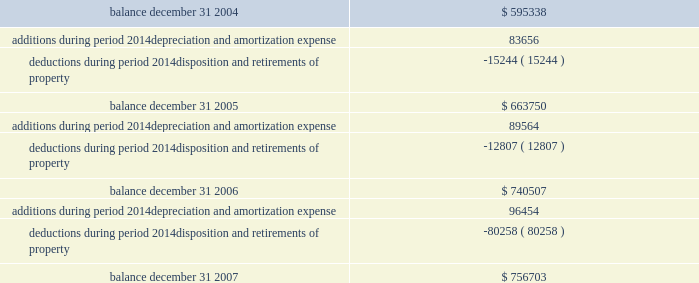Federal realty investment trust schedule iii summary of real estate and accumulated depreciation 2014continued three years ended december 31 , 2007 reconciliation of accumulated depreciation and amortization ( in thousands ) .

What is the variation of the additions during 2005 and 2006 , in thousands of dollars? 
Rationale: it is the difference between those addition values .
Computations: (89564 - 83656)
Answer: 5908.0. 